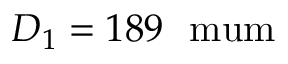<formula> <loc_0><loc_0><loc_500><loc_500>D _ { 1 } = 1 8 9 \ m u m</formula> 